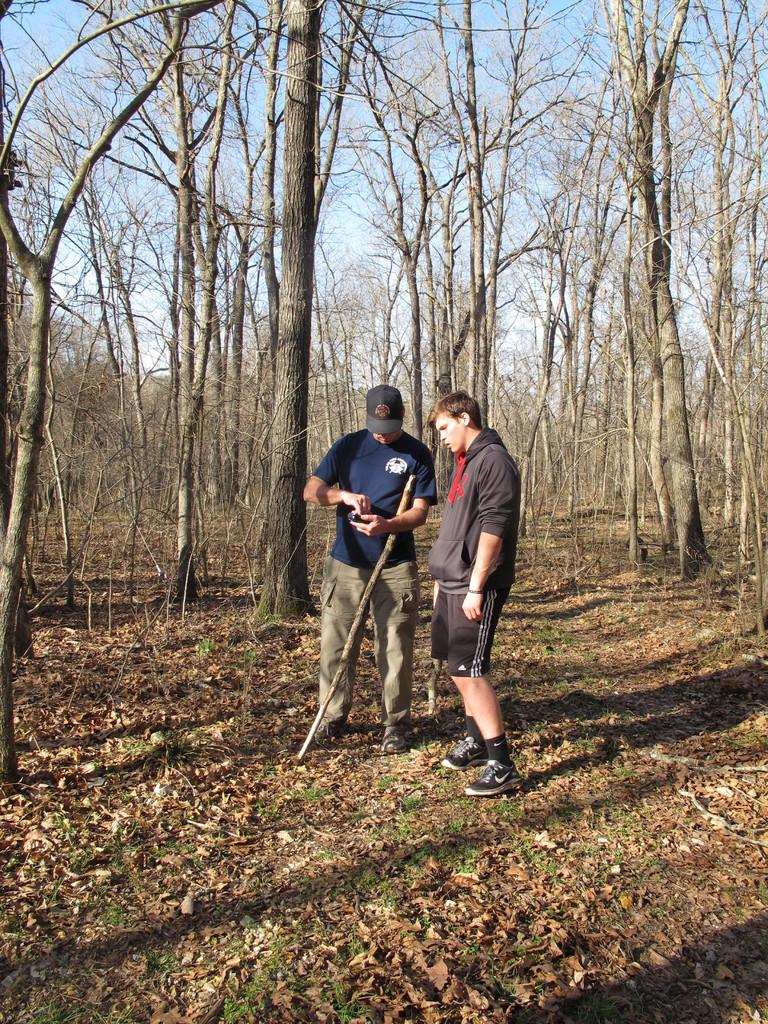How many people are in the image? There are two men standing in the image. What is one of the men holding in his hand? One man is holding a stick in his hand. What can be seen in the background of the image? There are trees visible in the background of the image. What type of haircut does the man with the stick have in the image? There is no information about the man's haircut in the image. How much tax is being discussed by the two men in the image? There is no indication of a discussion about tax in the image. 